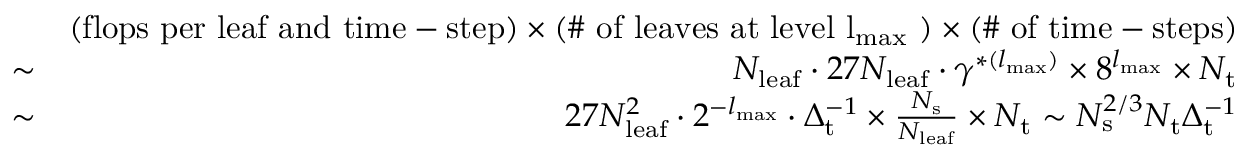Convert formula to latex. <formula><loc_0><loc_0><loc_500><loc_500>\begin{array} { r l r } & { ( f l o p s p e r l e a f a n d t i m e - s t e p ) \times ( \# o f l e a v e s a t l e v e l { l _ { { \mathrm { \max } } } } ) \times ( \# o f t i m e - s t e p s ) } \\ & { \sim } & { N _ { l e a f } \cdot 2 7 N _ { l e a f } \cdot \gamma ^ { * ( { l _ { \max } } ) } \times 8 ^ { { l _ { \max } } } \times N _ { t } } \\ & { \sim } & { 2 7 N _ { l e a f } ^ { 2 } \cdot 2 ^ { - { l _ { \max } } } \cdot \Delta _ { t } ^ { - 1 } \times \frac { N _ { s } } { N _ { l e a f } } \times N _ { t } \sim N _ { s } ^ { 2 / 3 } N _ { t } \Delta _ { t } ^ { - 1 } } \end{array}</formula> 